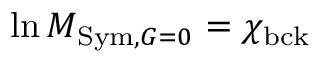Convert formula to latex. <formula><loc_0><loc_0><loc_500><loc_500>\ln M _ { S y m , G = 0 } = \chi _ { b c k }</formula> 